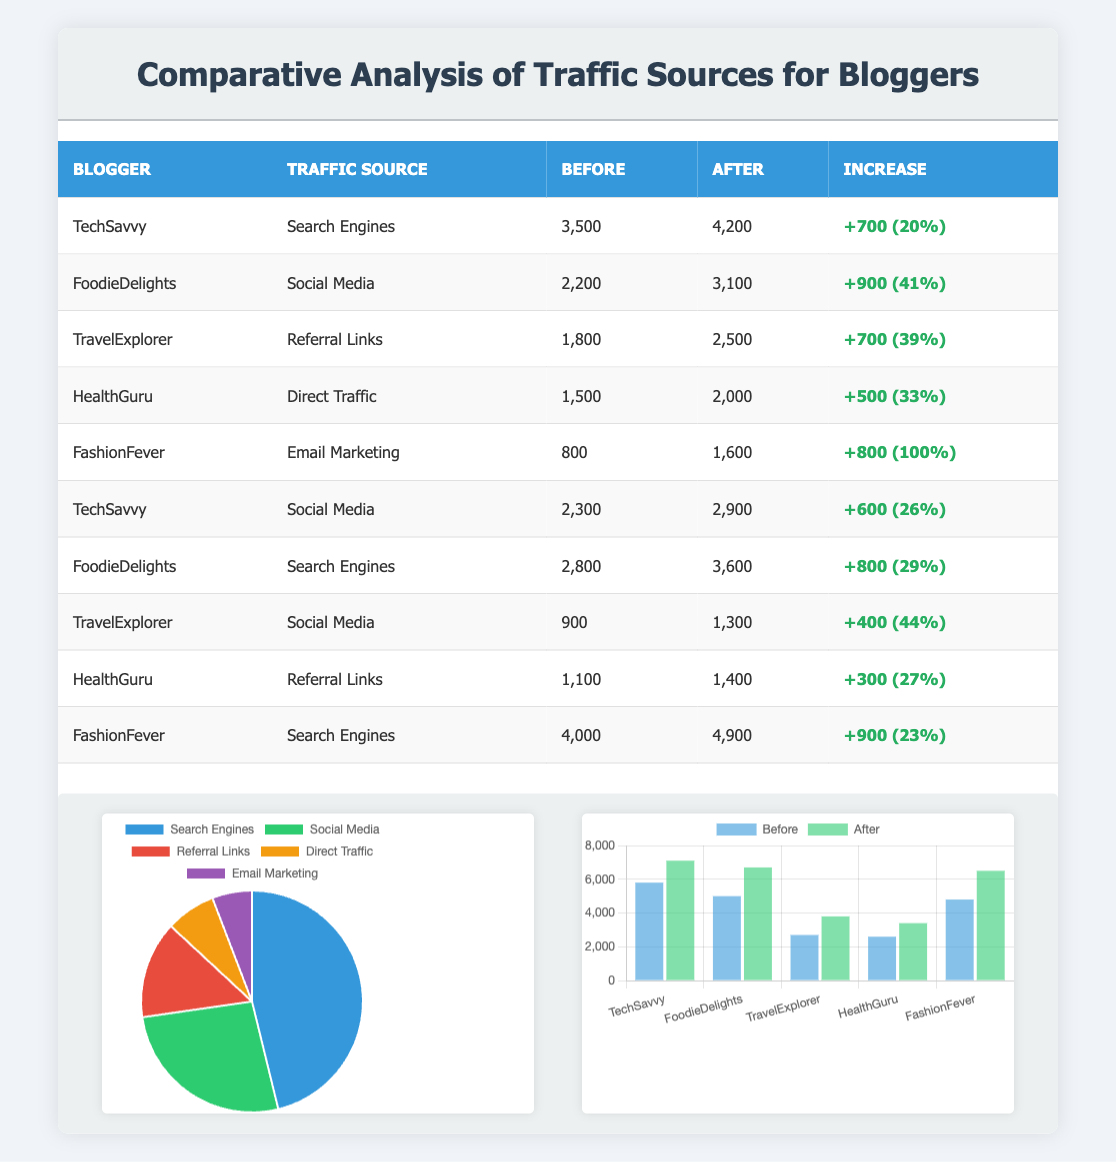What was the traffic from Search Engines for TechSavvy before using the product? The table shows that TrafficSavvy had 3,500 visits from Search Engines before using the product, which is directly listed under the "Before" column for their specific traffic source.
Answer: 3,500 Which blogger saw the highest percentage increase in traffic from Social Media? By examining the percentage increases for Social Media traffic, FoodieDelights had an increase of 41% from 2,200 to 3,100 visits, while TravelExplorer had a 44% increase. However, FoodieDelights had a larger actual increase of 900 visits. Thus, FoodieDelights saw the highest percentage increase.
Answer: FoodieDelights Has HealthGuru's traffic from Direct Traffic increased after using the product? The table indicates that HealthGuru had 1,500 visits from Direct Traffic before and this increased to 2,000 visits after using the product. Therefore, HealthGuru's traffic from Direct Traffic has increased.
Answer: Yes What is the total increase in traffic from Search Engines for all bloggers combined? To find the total increase from Search Engines, we look for the "increase" column specifically for Search Engines: TechSavvy (700) + FoodieDelights (800) + FashionFever (900) = 2,400. Hence, the total increase from Search Engines is 2,400 visits.
Answer: 2,400 Which blogger had the least amount of traffic from Email Marketing before using the product? The table shows that FashionFever had the least traffic from Email Marketing before using the product, with only 800 visits listed under "Before."
Answer: FashionFever 